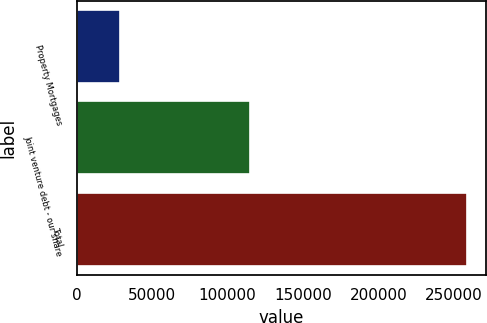<chart> <loc_0><loc_0><loc_500><loc_500><bar_chart><fcel>Property Mortgages<fcel>Joint venture debt - our share<fcel>Total<nl><fcel>28557<fcel>115130<fcel>258508<nl></chart> 